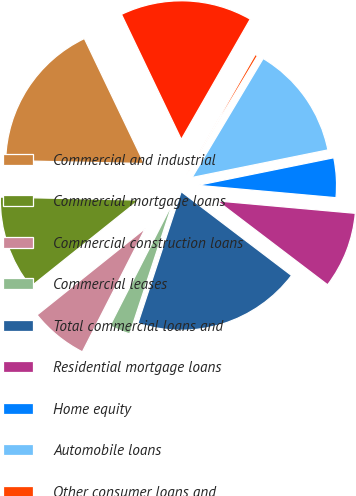Convert chart to OTSL. <chart><loc_0><loc_0><loc_500><loc_500><pie_chart><fcel>Commercial and industrial<fcel>Commercial mortgage loans<fcel>Commercial construction loans<fcel>Commercial leases<fcel>Total commercial loans and<fcel>Residential mortgage loans<fcel>Home equity<fcel>Automobile loans<fcel>Other consumer loans and<fcel>Total consumer loans and<nl><fcel>17.55%<fcel>11.08%<fcel>6.76%<fcel>2.45%<fcel>19.71%<fcel>8.92%<fcel>4.61%<fcel>13.24%<fcel>0.29%<fcel>15.39%<nl></chart> 